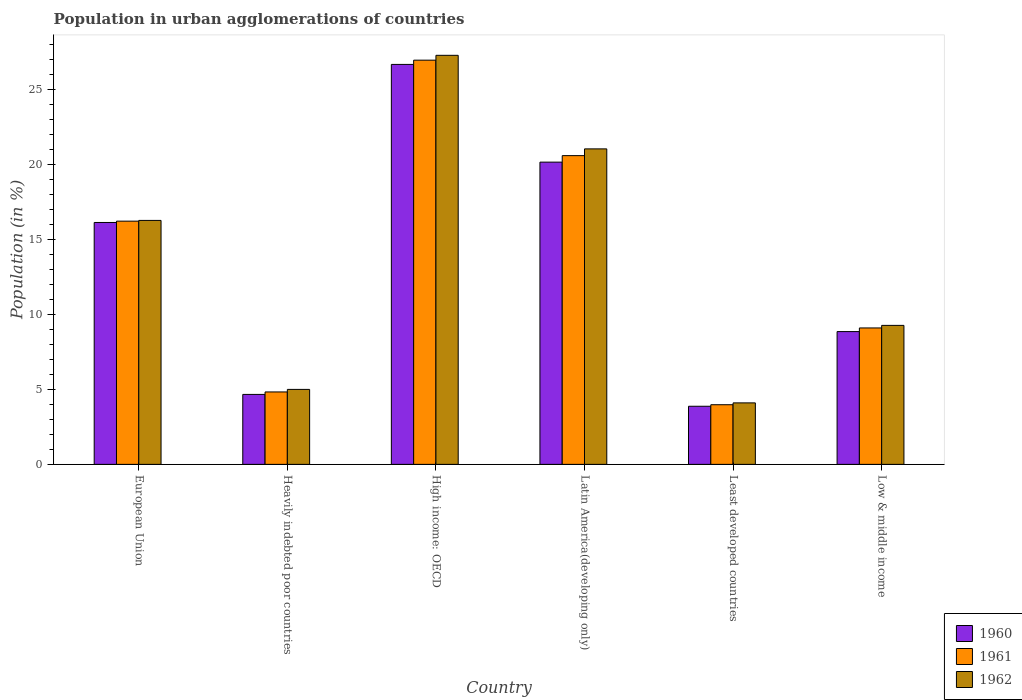How many different coloured bars are there?
Your answer should be compact. 3. How many groups of bars are there?
Provide a succinct answer. 6. Are the number of bars per tick equal to the number of legend labels?
Offer a very short reply. Yes. Are the number of bars on each tick of the X-axis equal?
Make the answer very short. Yes. How many bars are there on the 1st tick from the left?
Provide a short and direct response. 3. What is the label of the 2nd group of bars from the left?
Provide a short and direct response. Heavily indebted poor countries. In how many cases, is the number of bars for a given country not equal to the number of legend labels?
Ensure brevity in your answer.  0. What is the percentage of population in urban agglomerations in 1961 in High income: OECD?
Ensure brevity in your answer.  26.94. Across all countries, what is the maximum percentage of population in urban agglomerations in 1961?
Offer a terse response. 26.94. Across all countries, what is the minimum percentage of population in urban agglomerations in 1961?
Make the answer very short. 3.98. In which country was the percentage of population in urban agglomerations in 1961 maximum?
Offer a terse response. High income: OECD. In which country was the percentage of population in urban agglomerations in 1961 minimum?
Ensure brevity in your answer.  Least developed countries. What is the total percentage of population in urban agglomerations in 1960 in the graph?
Ensure brevity in your answer.  80.32. What is the difference between the percentage of population in urban agglomerations in 1961 in Heavily indebted poor countries and that in Latin America(developing only)?
Your answer should be very brief. -15.75. What is the difference between the percentage of population in urban agglomerations in 1960 in Low & middle income and the percentage of population in urban agglomerations in 1961 in European Union?
Provide a succinct answer. -7.36. What is the average percentage of population in urban agglomerations in 1962 per country?
Your response must be concise. 13.82. What is the difference between the percentage of population in urban agglomerations of/in 1960 and percentage of population in urban agglomerations of/in 1961 in High income: OECD?
Ensure brevity in your answer.  -0.28. In how many countries, is the percentage of population in urban agglomerations in 1960 greater than 16 %?
Provide a succinct answer. 3. What is the ratio of the percentage of population in urban agglomerations in 1960 in European Union to that in High income: OECD?
Ensure brevity in your answer.  0.6. Is the difference between the percentage of population in urban agglomerations in 1960 in Heavily indebted poor countries and Low & middle income greater than the difference between the percentage of population in urban agglomerations in 1961 in Heavily indebted poor countries and Low & middle income?
Give a very brief answer. Yes. What is the difference between the highest and the second highest percentage of population in urban agglomerations in 1960?
Your answer should be very brief. -10.54. What is the difference between the highest and the lowest percentage of population in urban agglomerations in 1962?
Give a very brief answer. 23.17. In how many countries, is the percentage of population in urban agglomerations in 1961 greater than the average percentage of population in urban agglomerations in 1961 taken over all countries?
Offer a very short reply. 3. What does the 3rd bar from the left in European Union represents?
Make the answer very short. 1962. What is the difference between two consecutive major ticks on the Y-axis?
Ensure brevity in your answer.  5. Does the graph contain any zero values?
Offer a terse response. No. Does the graph contain grids?
Give a very brief answer. No. How many legend labels are there?
Your answer should be compact. 3. What is the title of the graph?
Provide a short and direct response. Population in urban agglomerations of countries. What is the label or title of the X-axis?
Offer a very short reply. Country. What is the label or title of the Y-axis?
Give a very brief answer. Population (in %). What is the Population (in %) of 1960 in European Union?
Offer a terse response. 16.12. What is the Population (in %) of 1961 in European Union?
Offer a very short reply. 16.21. What is the Population (in %) in 1962 in European Union?
Your answer should be compact. 16.26. What is the Population (in %) in 1960 in Heavily indebted poor countries?
Keep it short and to the point. 4.66. What is the Population (in %) in 1961 in Heavily indebted poor countries?
Make the answer very short. 4.83. What is the Population (in %) of 1962 in Heavily indebted poor countries?
Ensure brevity in your answer.  5. What is the Population (in %) of 1960 in High income: OECD?
Keep it short and to the point. 26.66. What is the Population (in %) of 1961 in High income: OECD?
Your response must be concise. 26.94. What is the Population (in %) of 1962 in High income: OECD?
Your answer should be very brief. 27.27. What is the Population (in %) of 1960 in Latin America(developing only)?
Keep it short and to the point. 20.15. What is the Population (in %) in 1961 in Latin America(developing only)?
Your response must be concise. 20.58. What is the Population (in %) in 1962 in Latin America(developing only)?
Your answer should be compact. 21.03. What is the Population (in %) of 1960 in Least developed countries?
Your answer should be very brief. 3.87. What is the Population (in %) of 1961 in Least developed countries?
Provide a short and direct response. 3.98. What is the Population (in %) in 1962 in Least developed countries?
Make the answer very short. 4.1. What is the Population (in %) in 1960 in Low & middle income?
Ensure brevity in your answer.  8.85. What is the Population (in %) in 1961 in Low & middle income?
Provide a short and direct response. 9.09. What is the Population (in %) of 1962 in Low & middle income?
Provide a short and direct response. 9.27. Across all countries, what is the maximum Population (in %) of 1960?
Your answer should be compact. 26.66. Across all countries, what is the maximum Population (in %) of 1961?
Your answer should be very brief. 26.94. Across all countries, what is the maximum Population (in %) in 1962?
Provide a succinct answer. 27.27. Across all countries, what is the minimum Population (in %) of 1960?
Offer a very short reply. 3.87. Across all countries, what is the minimum Population (in %) of 1961?
Provide a succinct answer. 3.98. Across all countries, what is the minimum Population (in %) of 1962?
Provide a short and direct response. 4.1. What is the total Population (in %) of 1960 in the graph?
Give a very brief answer. 80.32. What is the total Population (in %) in 1961 in the graph?
Keep it short and to the point. 81.64. What is the total Population (in %) of 1962 in the graph?
Your response must be concise. 82.92. What is the difference between the Population (in %) in 1960 in European Union and that in Heavily indebted poor countries?
Ensure brevity in your answer.  11.46. What is the difference between the Population (in %) in 1961 in European Union and that in Heavily indebted poor countries?
Offer a terse response. 11.39. What is the difference between the Population (in %) in 1962 in European Union and that in Heavily indebted poor countries?
Provide a succinct answer. 11.26. What is the difference between the Population (in %) in 1960 in European Union and that in High income: OECD?
Provide a short and direct response. -10.54. What is the difference between the Population (in %) in 1961 in European Union and that in High income: OECD?
Provide a succinct answer. -10.73. What is the difference between the Population (in %) of 1962 in European Union and that in High income: OECD?
Offer a very short reply. -11. What is the difference between the Population (in %) of 1960 in European Union and that in Latin America(developing only)?
Provide a succinct answer. -4.02. What is the difference between the Population (in %) in 1961 in European Union and that in Latin America(developing only)?
Offer a terse response. -4.37. What is the difference between the Population (in %) in 1962 in European Union and that in Latin America(developing only)?
Make the answer very short. -4.77. What is the difference between the Population (in %) of 1960 in European Union and that in Least developed countries?
Provide a short and direct response. 12.25. What is the difference between the Population (in %) in 1961 in European Union and that in Least developed countries?
Provide a succinct answer. 12.24. What is the difference between the Population (in %) in 1962 in European Union and that in Least developed countries?
Offer a very short reply. 12.16. What is the difference between the Population (in %) in 1960 in European Union and that in Low & middle income?
Your response must be concise. 7.27. What is the difference between the Population (in %) in 1961 in European Union and that in Low & middle income?
Offer a very short reply. 7.12. What is the difference between the Population (in %) of 1962 in European Union and that in Low & middle income?
Ensure brevity in your answer.  7. What is the difference between the Population (in %) of 1960 in Heavily indebted poor countries and that in High income: OECD?
Your answer should be very brief. -22. What is the difference between the Population (in %) of 1961 in Heavily indebted poor countries and that in High income: OECD?
Provide a short and direct response. -22.12. What is the difference between the Population (in %) of 1962 in Heavily indebted poor countries and that in High income: OECD?
Your answer should be compact. -22.27. What is the difference between the Population (in %) of 1960 in Heavily indebted poor countries and that in Latin America(developing only)?
Your response must be concise. -15.48. What is the difference between the Population (in %) of 1961 in Heavily indebted poor countries and that in Latin America(developing only)?
Offer a terse response. -15.75. What is the difference between the Population (in %) in 1962 in Heavily indebted poor countries and that in Latin America(developing only)?
Offer a terse response. -16.03. What is the difference between the Population (in %) of 1960 in Heavily indebted poor countries and that in Least developed countries?
Your response must be concise. 0.79. What is the difference between the Population (in %) of 1961 in Heavily indebted poor countries and that in Least developed countries?
Ensure brevity in your answer.  0.85. What is the difference between the Population (in %) of 1962 in Heavily indebted poor countries and that in Least developed countries?
Provide a succinct answer. 0.9. What is the difference between the Population (in %) of 1960 in Heavily indebted poor countries and that in Low & middle income?
Give a very brief answer. -4.19. What is the difference between the Population (in %) of 1961 in Heavily indebted poor countries and that in Low & middle income?
Your answer should be very brief. -4.27. What is the difference between the Population (in %) in 1962 in Heavily indebted poor countries and that in Low & middle income?
Offer a very short reply. -4.27. What is the difference between the Population (in %) of 1960 in High income: OECD and that in Latin America(developing only)?
Make the answer very short. 6.51. What is the difference between the Population (in %) of 1961 in High income: OECD and that in Latin America(developing only)?
Offer a terse response. 6.36. What is the difference between the Population (in %) in 1962 in High income: OECD and that in Latin America(developing only)?
Your answer should be compact. 6.24. What is the difference between the Population (in %) in 1960 in High income: OECD and that in Least developed countries?
Your answer should be very brief. 22.79. What is the difference between the Population (in %) in 1961 in High income: OECD and that in Least developed countries?
Make the answer very short. 22.97. What is the difference between the Population (in %) of 1962 in High income: OECD and that in Least developed countries?
Make the answer very short. 23.17. What is the difference between the Population (in %) in 1960 in High income: OECD and that in Low & middle income?
Offer a very short reply. 17.81. What is the difference between the Population (in %) of 1961 in High income: OECD and that in Low & middle income?
Offer a terse response. 17.85. What is the difference between the Population (in %) in 1962 in High income: OECD and that in Low & middle income?
Ensure brevity in your answer.  18. What is the difference between the Population (in %) in 1960 in Latin America(developing only) and that in Least developed countries?
Offer a terse response. 16.27. What is the difference between the Population (in %) in 1961 in Latin America(developing only) and that in Least developed countries?
Keep it short and to the point. 16.61. What is the difference between the Population (in %) of 1962 in Latin America(developing only) and that in Least developed countries?
Keep it short and to the point. 16.93. What is the difference between the Population (in %) of 1960 in Latin America(developing only) and that in Low & middle income?
Make the answer very short. 11.3. What is the difference between the Population (in %) of 1961 in Latin America(developing only) and that in Low & middle income?
Keep it short and to the point. 11.49. What is the difference between the Population (in %) in 1962 in Latin America(developing only) and that in Low & middle income?
Your answer should be very brief. 11.77. What is the difference between the Population (in %) of 1960 in Least developed countries and that in Low & middle income?
Provide a short and direct response. -4.98. What is the difference between the Population (in %) in 1961 in Least developed countries and that in Low & middle income?
Ensure brevity in your answer.  -5.12. What is the difference between the Population (in %) of 1962 in Least developed countries and that in Low & middle income?
Ensure brevity in your answer.  -5.17. What is the difference between the Population (in %) of 1960 in European Union and the Population (in %) of 1961 in Heavily indebted poor countries?
Give a very brief answer. 11.3. What is the difference between the Population (in %) of 1960 in European Union and the Population (in %) of 1962 in Heavily indebted poor countries?
Provide a succinct answer. 11.13. What is the difference between the Population (in %) in 1961 in European Union and the Population (in %) in 1962 in Heavily indebted poor countries?
Give a very brief answer. 11.22. What is the difference between the Population (in %) in 1960 in European Union and the Population (in %) in 1961 in High income: OECD?
Provide a succinct answer. -10.82. What is the difference between the Population (in %) in 1960 in European Union and the Population (in %) in 1962 in High income: OECD?
Make the answer very short. -11.14. What is the difference between the Population (in %) in 1961 in European Union and the Population (in %) in 1962 in High income: OECD?
Offer a very short reply. -11.05. What is the difference between the Population (in %) of 1960 in European Union and the Population (in %) of 1961 in Latin America(developing only)?
Make the answer very short. -4.46. What is the difference between the Population (in %) of 1960 in European Union and the Population (in %) of 1962 in Latin America(developing only)?
Provide a short and direct response. -4.91. What is the difference between the Population (in %) of 1961 in European Union and the Population (in %) of 1962 in Latin America(developing only)?
Provide a short and direct response. -4.82. What is the difference between the Population (in %) in 1960 in European Union and the Population (in %) in 1961 in Least developed countries?
Your answer should be compact. 12.15. What is the difference between the Population (in %) of 1960 in European Union and the Population (in %) of 1962 in Least developed countries?
Your answer should be very brief. 12.03. What is the difference between the Population (in %) of 1961 in European Union and the Population (in %) of 1962 in Least developed countries?
Provide a succinct answer. 12.11. What is the difference between the Population (in %) in 1960 in European Union and the Population (in %) in 1961 in Low & middle income?
Provide a short and direct response. 7.03. What is the difference between the Population (in %) in 1960 in European Union and the Population (in %) in 1962 in Low & middle income?
Give a very brief answer. 6.86. What is the difference between the Population (in %) in 1961 in European Union and the Population (in %) in 1962 in Low & middle income?
Your answer should be very brief. 6.95. What is the difference between the Population (in %) of 1960 in Heavily indebted poor countries and the Population (in %) of 1961 in High income: OECD?
Your answer should be very brief. -22.28. What is the difference between the Population (in %) in 1960 in Heavily indebted poor countries and the Population (in %) in 1962 in High income: OECD?
Give a very brief answer. -22.6. What is the difference between the Population (in %) of 1961 in Heavily indebted poor countries and the Population (in %) of 1962 in High income: OECD?
Provide a succinct answer. -22.44. What is the difference between the Population (in %) in 1960 in Heavily indebted poor countries and the Population (in %) in 1961 in Latin America(developing only)?
Provide a succinct answer. -15.92. What is the difference between the Population (in %) of 1960 in Heavily indebted poor countries and the Population (in %) of 1962 in Latin America(developing only)?
Provide a succinct answer. -16.37. What is the difference between the Population (in %) of 1961 in Heavily indebted poor countries and the Population (in %) of 1962 in Latin America(developing only)?
Make the answer very short. -16.2. What is the difference between the Population (in %) in 1960 in Heavily indebted poor countries and the Population (in %) in 1961 in Least developed countries?
Your answer should be compact. 0.69. What is the difference between the Population (in %) in 1960 in Heavily indebted poor countries and the Population (in %) in 1962 in Least developed countries?
Provide a short and direct response. 0.56. What is the difference between the Population (in %) of 1961 in Heavily indebted poor countries and the Population (in %) of 1962 in Least developed countries?
Provide a succinct answer. 0.73. What is the difference between the Population (in %) of 1960 in Heavily indebted poor countries and the Population (in %) of 1961 in Low & middle income?
Keep it short and to the point. -4.43. What is the difference between the Population (in %) in 1960 in Heavily indebted poor countries and the Population (in %) in 1962 in Low & middle income?
Keep it short and to the point. -4.6. What is the difference between the Population (in %) in 1961 in Heavily indebted poor countries and the Population (in %) in 1962 in Low & middle income?
Ensure brevity in your answer.  -4.44. What is the difference between the Population (in %) of 1960 in High income: OECD and the Population (in %) of 1961 in Latin America(developing only)?
Provide a succinct answer. 6.08. What is the difference between the Population (in %) in 1960 in High income: OECD and the Population (in %) in 1962 in Latin America(developing only)?
Offer a terse response. 5.63. What is the difference between the Population (in %) in 1961 in High income: OECD and the Population (in %) in 1962 in Latin America(developing only)?
Ensure brevity in your answer.  5.91. What is the difference between the Population (in %) in 1960 in High income: OECD and the Population (in %) in 1961 in Least developed countries?
Give a very brief answer. 22.69. What is the difference between the Population (in %) of 1960 in High income: OECD and the Population (in %) of 1962 in Least developed countries?
Your answer should be compact. 22.56. What is the difference between the Population (in %) in 1961 in High income: OECD and the Population (in %) in 1962 in Least developed countries?
Make the answer very short. 22.85. What is the difference between the Population (in %) in 1960 in High income: OECD and the Population (in %) in 1961 in Low & middle income?
Keep it short and to the point. 17.57. What is the difference between the Population (in %) of 1960 in High income: OECD and the Population (in %) of 1962 in Low & middle income?
Offer a very short reply. 17.4. What is the difference between the Population (in %) of 1961 in High income: OECD and the Population (in %) of 1962 in Low & middle income?
Ensure brevity in your answer.  17.68. What is the difference between the Population (in %) of 1960 in Latin America(developing only) and the Population (in %) of 1961 in Least developed countries?
Ensure brevity in your answer.  16.17. What is the difference between the Population (in %) in 1960 in Latin America(developing only) and the Population (in %) in 1962 in Least developed countries?
Ensure brevity in your answer.  16.05. What is the difference between the Population (in %) of 1961 in Latin America(developing only) and the Population (in %) of 1962 in Least developed countries?
Give a very brief answer. 16.48. What is the difference between the Population (in %) in 1960 in Latin America(developing only) and the Population (in %) in 1961 in Low & middle income?
Make the answer very short. 11.05. What is the difference between the Population (in %) of 1960 in Latin America(developing only) and the Population (in %) of 1962 in Low & middle income?
Your answer should be compact. 10.88. What is the difference between the Population (in %) of 1961 in Latin America(developing only) and the Population (in %) of 1962 in Low & middle income?
Provide a succinct answer. 11.32. What is the difference between the Population (in %) in 1960 in Least developed countries and the Population (in %) in 1961 in Low & middle income?
Your answer should be very brief. -5.22. What is the difference between the Population (in %) of 1960 in Least developed countries and the Population (in %) of 1962 in Low & middle income?
Ensure brevity in your answer.  -5.39. What is the difference between the Population (in %) of 1961 in Least developed countries and the Population (in %) of 1962 in Low & middle income?
Keep it short and to the point. -5.29. What is the average Population (in %) in 1960 per country?
Your answer should be compact. 13.39. What is the average Population (in %) in 1961 per country?
Keep it short and to the point. 13.61. What is the average Population (in %) in 1962 per country?
Give a very brief answer. 13.82. What is the difference between the Population (in %) in 1960 and Population (in %) in 1961 in European Union?
Provide a succinct answer. -0.09. What is the difference between the Population (in %) in 1960 and Population (in %) in 1962 in European Union?
Ensure brevity in your answer.  -0.14. What is the difference between the Population (in %) in 1961 and Population (in %) in 1962 in European Union?
Ensure brevity in your answer.  -0.05. What is the difference between the Population (in %) in 1960 and Population (in %) in 1961 in Heavily indebted poor countries?
Provide a short and direct response. -0.16. What is the difference between the Population (in %) of 1960 and Population (in %) of 1962 in Heavily indebted poor countries?
Provide a short and direct response. -0.33. What is the difference between the Population (in %) of 1961 and Population (in %) of 1962 in Heavily indebted poor countries?
Your answer should be compact. -0.17. What is the difference between the Population (in %) in 1960 and Population (in %) in 1961 in High income: OECD?
Make the answer very short. -0.28. What is the difference between the Population (in %) of 1960 and Population (in %) of 1962 in High income: OECD?
Your answer should be very brief. -0.61. What is the difference between the Population (in %) of 1961 and Population (in %) of 1962 in High income: OECD?
Provide a succinct answer. -0.32. What is the difference between the Population (in %) of 1960 and Population (in %) of 1961 in Latin America(developing only)?
Keep it short and to the point. -0.43. What is the difference between the Population (in %) in 1960 and Population (in %) in 1962 in Latin America(developing only)?
Provide a succinct answer. -0.88. What is the difference between the Population (in %) in 1961 and Population (in %) in 1962 in Latin America(developing only)?
Keep it short and to the point. -0.45. What is the difference between the Population (in %) in 1960 and Population (in %) in 1961 in Least developed countries?
Offer a very short reply. -0.1. What is the difference between the Population (in %) in 1960 and Population (in %) in 1962 in Least developed countries?
Offer a terse response. -0.23. What is the difference between the Population (in %) of 1961 and Population (in %) of 1962 in Least developed countries?
Your answer should be compact. -0.12. What is the difference between the Population (in %) in 1960 and Population (in %) in 1961 in Low & middle income?
Offer a terse response. -0.24. What is the difference between the Population (in %) in 1960 and Population (in %) in 1962 in Low & middle income?
Keep it short and to the point. -0.41. What is the difference between the Population (in %) of 1961 and Population (in %) of 1962 in Low & middle income?
Provide a succinct answer. -0.17. What is the ratio of the Population (in %) in 1960 in European Union to that in Heavily indebted poor countries?
Keep it short and to the point. 3.46. What is the ratio of the Population (in %) of 1961 in European Union to that in Heavily indebted poor countries?
Keep it short and to the point. 3.36. What is the ratio of the Population (in %) of 1962 in European Union to that in Heavily indebted poor countries?
Your response must be concise. 3.25. What is the ratio of the Population (in %) in 1960 in European Union to that in High income: OECD?
Your answer should be compact. 0.6. What is the ratio of the Population (in %) in 1961 in European Union to that in High income: OECD?
Your response must be concise. 0.6. What is the ratio of the Population (in %) of 1962 in European Union to that in High income: OECD?
Keep it short and to the point. 0.6. What is the ratio of the Population (in %) of 1960 in European Union to that in Latin America(developing only)?
Offer a very short reply. 0.8. What is the ratio of the Population (in %) in 1961 in European Union to that in Latin America(developing only)?
Offer a very short reply. 0.79. What is the ratio of the Population (in %) of 1962 in European Union to that in Latin America(developing only)?
Ensure brevity in your answer.  0.77. What is the ratio of the Population (in %) of 1960 in European Union to that in Least developed countries?
Your answer should be compact. 4.16. What is the ratio of the Population (in %) of 1961 in European Union to that in Least developed countries?
Provide a succinct answer. 4.08. What is the ratio of the Population (in %) of 1962 in European Union to that in Least developed countries?
Keep it short and to the point. 3.97. What is the ratio of the Population (in %) in 1960 in European Union to that in Low & middle income?
Ensure brevity in your answer.  1.82. What is the ratio of the Population (in %) of 1961 in European Union to that in Low & middle income?
Make the answer very short. 1.78. What is the ratio of the Population (in %) of 1962 in European Union to that in Low & middle income?
Your answer should be very brief. 1.76. What is the ratio of the Population (in %) in 1960 in Heavily indebted poor countries to that in High income: OECD?
Offer a terse response. 0.17. What is the ratio of the Population (in %) in 1961 in Heavily indebted poor countries to that in High income: OECD?
Provide a short and direct response. 0.18. What is the ratio of the Population (in %) of 1962 in Heavily indebted poor countries to that in High income: OECD?
Your answer should be compact. 0.18. What is the ratio of the Population (in %) of 1960 in Heavily indebted poor countries to that in Latin America(developing only)?
Offer a very short reply. 0.23. What is the ratio of the Population (in %) of 1961 in Heavily indebted poor countries to that in Latin America(developing only)?
Provide a short and direct response. 0.23. What is the ratio of the Population (in %) of 1962 in Heavily indebted poor countries to that in Latin America(developing only)?
Your response must be concise. 0.24. What is the ratio of the Population (in %) in 1960 in Heavily indebted poor countries to that in Least developed countries?
Make the answer very short. 1.2. What is the ratio of the Population (in %) of 1961 in Heavily indebted poor countries to that in Least developed countries?
Offer a very short reply. 1.21. What is the ratio of the Population (in %) in 1962 in Heavily indebted poor countries to that in Least developed countries?
Ensure brevity in your answer.  1.22. What is the ratio of the Population (in %) of 1960 in Heavily indebted poor countries to that in Low & middle income?
Give a very brief answer. 0.53. What is the ratio of the Population (in %) in 1961 in Heavily indebted poor countries to that in Low & middle income?
Make the answer very short. 0.53. What is the ratio of the Population (in %) of 1962 in Heavily indebted poor countries to that in Low & middle income?
Ensure brevity in your answer.  0.54. What is the ratio of the Population (in %) in 1960 in High income: OECD to that in Latin America(developing only)?
Provide a succinct answer. 1.32. What is the ratio of the Population (in %) in 1961 in High income: OECD to that in Latin America(developing only)?
Make the answer very short. 1.31. What is the ratio of the Population (in %) of 1962 in High income: OECD to that in Latin America(developing only)?
Offer a very short reply. 1.3. What is the ratio of the Population (in %) in 1960 in High income: OECD to that in Least developed countries?
Make the answer very short. 6.88. What is the ratio of the Population (in %) of 1961 in High income: OECD to that in Least developed countries?
Provide a short and direct response. 6.78. What is the ratio of the Population (in %) of 1962 in High income: OECD to that in Least developed countries?
Give a very brief answer. 6.65. What is the ratio of the Population (in %) in 1960 in High income: OECD to that in Low & middle income?
Offer a very short reply. 3.01. What is the ratio of the Population (in %) of 1961 in High income: OECD to that in Low & middle income?
Provide a short and direct response. 2.96. What is the ratio of the Population (in %) in 1962 in High income: OECD to that in Low & middle income?
Provide a short and direct response. 2.94. What is the ratio of the Population (in %) of 1960 in Latin America(developing only) to that in Least developed countries?
Ensure brevity in your answer.  5.2. What is the ratio of the Population (in %) of 1961 in Latin America(developing only) to that in Least developed countries?
Offer a terse response. 5.18. What is the ratio of the Population (in %) of 1962 in Latin America(developing only) to that in Least developed countries?
Your response must be concise. 5.13. What is the ratio of the Population (in %) of 1960 in Latin America(developing only) to that in Low & middle income?
Your response must be concise. 2.28. What is the ratio of the Population (in %) in 1961 in Latin America(developing only) to that in Low & middle income?
Your answer should be compact. 2.26. What is the ratio of the Population (in %) of 1962 in Latin America(developing only) to that in Low & middle income?
Ensure brevity in your answer.  2.27. What is the ratio of the Population (in %) in 1960 in Least developed countries to that in Low & middle income?
Your answer should be very brief. 0.44. What is the ratio of the Population (in %) of 1961 in Least developed countries to that in Low & middle income?
Keep it short and to the point. 0.44. What is the ratio of the Population (in %) of 1962 in Least developed countries to that in Low & middle income?
Offer a very short reply. 0.44. What is the difference between the highest and the second highest Population (in %) of 1960?
Make the answer very short. 6.51. What is the difference between the highest and the second highest Population (in %) in 1961?
Offer a terse response. 6.36. What is the difference between the highest and the second highest Population (in %) in 1962?
Keep it short and to the point. 6.24. What is the difference between the highest and the lowest Population (in %) in 1960?
Your answer should be compact. 22.79. What is the difference between the highest and the lowest Population (in %) in 1961?
Offer a very short reply. 22.97. What is the difference between the highest and the lowest Population (in %) of 1962?
Your response must be concise. 23.17. 